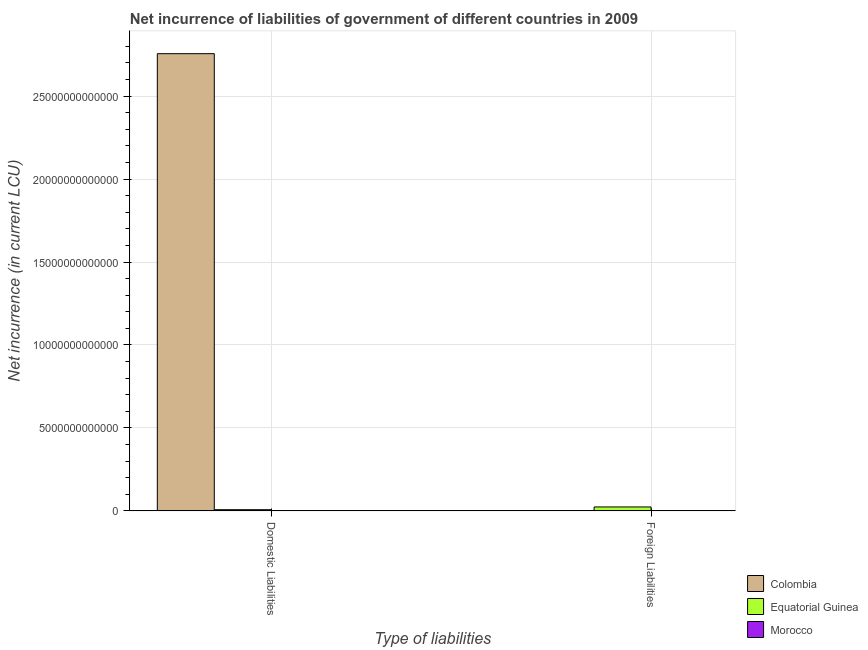How many different coloured bars are there?
Give a very brief answer. 3. How many bars are there on the 2nd tick from the left?
Provide a succinct answer. 2. What is the label of the 1st group of bars from the left?
Offer a terse response. Domestic Liabilities. What is the net incurrence of domestic liabilities in Equatorial Guinea?
Provide a succinct answer. 7.17e+1. Across all countries, what is the maximum net incurrence of foreign liabilities?
Provide a succinct answer. 2.38e+11. Across all countries, what is the minimum net incurrence of domestic liabilities?
Give a very brief answer. 1.02e+09. What is the total net incurrence of foreign liabilities in the graph?
Provide a short and direct response. 2.51e+11. What is the difference between the net incurrence of domestic liabilities in Colombia and that in Morocco?
Keep it short and to the point. 2.76e+13. What is the difference between the net incurrence of domestic liabilities in Equatorial Guinea and the net incurrence of foreign liabilities in Colombia?
Give a very brief answer. 7.17e+1. What is the average net incurrence of foreign liabilities per country?
Offer a very short reply. 8.36e+1. What is the difference between the net incurrence of foreign liabilities and net incurrence of domestic liabilities in Equatorial Guinea?
Offer a terse response. 1.67e+11. What is the ratio of the net incurrence of domestic liabilities in Equatorial Guinea to that in Morocco?
Provide a succinct answer. 70.32. Is the net incurrence of domestic liabilities in Morocco less than that in Equatorial Guinea?
Provide a short and direct response. Yes. How many bars are there?
Your answer should be very brief. 5. Are all the bars in the graph horizontal?
Your response must be concise. No. How many countries are there in the graph?
Give a very brief answer. 3. What is the difference between two consecutive major ticks on the Y-axis?
Your answer should be compact. 5.00e+12. Does the graph contain any zero values?
Your answer should be very brief. Yes. Does the graph contain grids?
Offer a terse response. Yes. Where does the legend appear in the graph?
Your response must be concise. Bottom right. How are the legend labels stacked?
Your response must be concise. Vertical. What is the title of the graph?
Your answer should be compact. Net incurrence of liabilities of government of different countries in 2009. Does "Marshall Islands" appear as one of the legend labels in the graph?
Provide a short and direct response. No. What is the label or title of the X-axis?
Offer a terse response. Type of liabilities. What is the label or title of the Y-axis?
Your response must be concise. Net incurrence (in current LCU). What is the Net incurrence (in current LCU) in Colombia in Domestic Liabilities?
Provide a succinct answer. 2.76e+13. What is the Net incurrence (in current LCU) in Equatorial Guinea in Domestic Liabilities?
Your response must be concise. 7.17e+1. What is the Net incurrence (in current LCU) in Morocco in Domestic Liabilities?
Your answer should be compact. 1.02e+09. What is the Net incurrence (in current LCU) in Equatorial Guinea in Foreign Liabilities?
Your response must be concise. 2.38e+11. What is the Net incurrence (in current LCU) of Morocco in Foreign Liabilities?
Provide a succinct answer. 1.27e+1. Across all Type of liabilities, what is the maximum Net incurrence (in current LCU) of Colombia?
Offer a very short reply. 2.76e+13. Across all Type of liabilities, what is the maximum Net incurrence (in current LCU) of Equatorial Guinea?
Make the answer very short. 2.38e+11. Across all Type of liabilities, what is the maximum Net incurrence (in current LCU) in Morocco?
Your answer should be very brief. 1.27e+1. Across all Type of liabilities, what is the minimum Net incurrence (in current LCU) in Equatorial Guinea?
Make the answer very short. 7.17e+1. Across all Type of liabilities, what is the minimum Net incurrence (in current LCU) in Morocco?
Provide a short and direct response. 1.02e+09. What is the total Net incurrence (in current LCU) of Colombia in the graph?
Give a very brief answer. 2.76e+13. What is the total Net incurrence (in current LCU) of Equatorial Guinea in the graph?
Your answer should be very brief. 3.10e+11. What is the total Net incurrence (in current LCU) of Morocco in the graph?
Offer a very short reply. 1.37e+1. What is the difference between the Net incurrence (in current LCU) in Equatorial Guinea in Domestic Liabilities and that in Foreign Liabilities?
Your answer should be compact. -1.67e+11. What is the difference between the Net incurrence (in current LCU) in Morocco in Domestic Liabilities and that in Foreign Liabilities?
Make the answer very short. -1.17e+1. What is the difference between the Net incurrence (in current LCU) in Colombia in Domestic Liabilities and the Net incurrence (in current LCU) in Equatorial Guinea in Foreign Liabilities?
Provide a short and direct response. 2.73e+13. What is the difference between the Net incurrence (in current LCU) of Colombia in Domestic Liabilities and the Net incurrence (in current LCU) of Morocco in Foreign Liabilities?
Offer a very short reply. 2.75e+13. What is the difference between the Net incurrence (in current LCU) in Equatorial Guinea in Domestic Liabilities and the Net incurrence (in current LCU) in Morocco in Foreign Liabilities?
Provide a succinct answer. 5.90e+1. What is the average Net incurrence (in current LCU) in Colombia per Type of liabilities?
Offer a terse response. 1.38e+13. What is the average Net incurrence (in current LCU) of Equatorial Guinea per Type of liabilities?
Make the answer very short. 1.55e+11. What is the average Net incurrence (in current LCU) in Morocco per Type of liabilities?
Give a very brief answer. 6.86e+09. What is the difference between the Net incurrence (in current LCU) in Colombia and Net incurrence (in current LCU) in Equatorial Guinea in Domestic Liabilities?
Offer a terse response. 2.75e+13. What is the difference between the Net incurrence (in current LCU) of Colombia and Net incurrence (in current LCU) of Morocco in Domestic Liabilities?
Provide a succinct answer. 2.76e+13. What is the difference between the Net incurrence (in current LCU) in Equatorial Guinea and Net incurrence (in current LCU) in Morocco in Domestic Liabilities?
Give a very brief answer. 7.07e+1. What is the difference between the Net incurrence (in current LCU) in Equatorial Guinea and Net incurrence (in current LCU) in Morocco in Foreign Liabilities?
Keep it short and to the point. 2.26e+11. What is the ratio of the Net incurrence (in current LCU) of Equatorial Guinea in Domestic Liabilities to that in Foreign Liabilities?
Your response must be concise. 0.3. What is the ratio of the Net incurrence (in current LCU) in Morocco in Domestic Liabilities to that in Foreign Liabilities?
Make the answer very short. 0.08. What is the difference between the highest and the second highest Net incurrence (in current LCU) in Equatorial Guinea?
Ensure brevity in your answer.  1.67e+11. What is the difference between the highest and the second highest Net incurrence (in current LCU) in Morocco?
Offer a very short reply. 1.17e+1. What is the difference between the highest and the lowest Net incurrence (in current LCU) in Colombia?
Provide a short and direct response. 2.76e+13. What is the difference between the highest and the lowest Net incurrence (in current LCU) of Equatorial Guinea?
Give a very brief answer. 1.67e+11. What is the difference between the highest and the lowest Net incurrence (in current LCU) of Morocco?
Your answer should be very brief. 1.17e+1. 